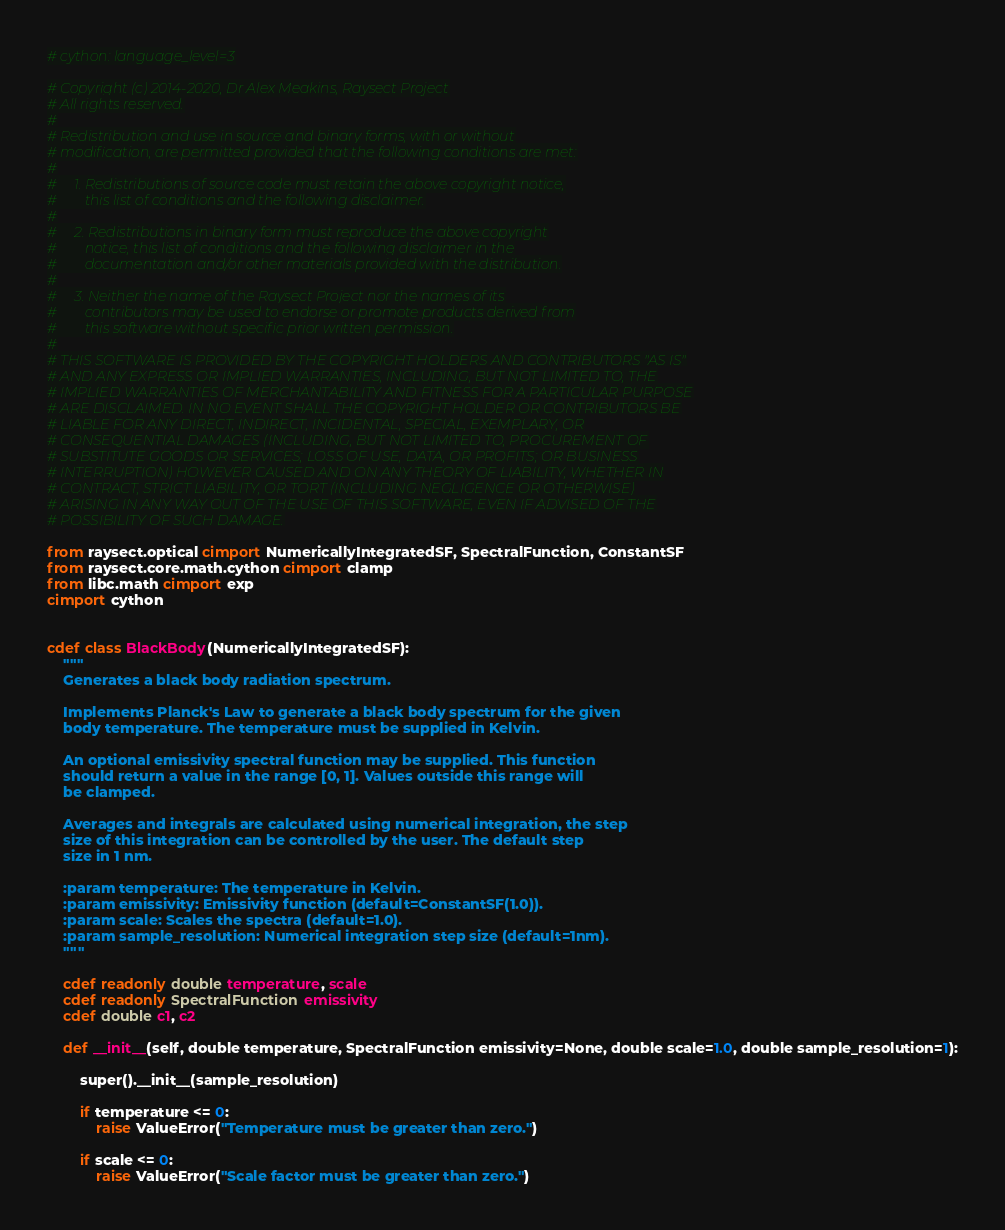Convert code to text. <code><loc_0><loc_0><loc_500><loc_500><_Cython_># cython: language_level=3

# Copyright (c) 2014-2020, Dr Alex Meakins, Raysect Project
# All rights reserved.
#
# Redistribution and use in source and binary forms, with or without
# modification, are permitted provided that the following conditions are met:
#
#     1. Redistributions of source code must retain the above copyright notice,
#        this list of conditions and the following disclaimer.
#
#     2. Redistributions in binary form must reproduce the above copyright
#        notice, this list of conditions and the following disclaimer in the
#        documentation and/or other materials provided with the distribution.
#
#     3. Neither the name of the Raysect Project nor the names of its
#        contributors may be used to endorse or promote products derived from
#        this software without specific prior written permission.
#
# THIS SOFTWARE IS PROVIDED BY THE COPYRIGHT HOLDERS AND CONTRIBUTORS "AS IS"
# AND ANY EXPRESS OR IMPLIED WARRANTIES, INCLUDING, BUT NOT LIMITED TO, THE
# IMPLIED WARRANTIES OF MERCHANTABILITY AND FITNESS FOR A PARTICULAR PURPOSE
# ARE DISCLAIMED. IN NO EVENT SHALL THE COPYRIGHT HOLDER OR CONTRIBUTORS BE
# LIABLE FOR ANY DIRECT, INDIRECT, INCIDENTAL, SPECIAL, EXEMPLARY, OR
# CONSEQUENTIAL DAMAGES (INCLUDING, BUT NOT LIMITED TO, PROCUREMENT OF
# SUBSTITUTE GOODS OR SERVICES; LOSS OF USE, DATA, OR PROFITS; OR BUSINESS
# INTERRUPTION) HOWEVER CAUSED AND ON ANY THEORY OF LIABILITY, WHETHER IN
# CONTRACT, STRICT LIABILITY, OR TORT (INCLUDING NEGLIGENCE OR OTHERWISE)
# ARISING IN ANY WAY OUT OF THE USE OF THIS SOFTWARE, EVEN IF ADVISED OF THE
# POSSIBILITY OF SUCH DAMAGE.

from raysect.optical cimport NumericallyIntegratedSF, SpectralFunction, ConstantSF
from raysect.core.math.cython cimport clamp
from libc.math cimport exp
cimport cython


cdef class BlackBody(NumericallyIntegratedSF):
    """
    Generates a black body radiation spectrum.

    Implements Planck's Law to generate a black body spectrum for the given
    body temperature. The temperature must be supplied in Kelvin.

    An optional emissivity spectral function may be supplied. This function
    should return a value in the range [0, 1]. Values outside this range will
    be clamped.

    Averages and integrals are calculated using numerical integration, the step
    size of this integration can be controlled by the user. The default step
    size in 1 nm.

    :param temperature: The temperature in Kelvin.
    :param emissivity: Emissivity function (default=ConstantSF(1.0)).
    :param scale: Scales the spectra (default=1.0).
    :param sample_resolution: Numerical integration step size (default=1nm).
    """

    cdef readonly double temperature, scale
    cdef readonly SpectralFunction emissivity
    cdef double c1, c2

    def __init__(self, double temperature, SpectralFunction emissivity=None, double scale=1.0, double sample_resolution=1):

        super().__init__(sample_resolution)

        if temperature <= 0:
            raise ValueError("Temperature must be greater than zero.")

        if scale <= 0:
            raise ValueError("Scale factor must be greater than zero.")
</code> 